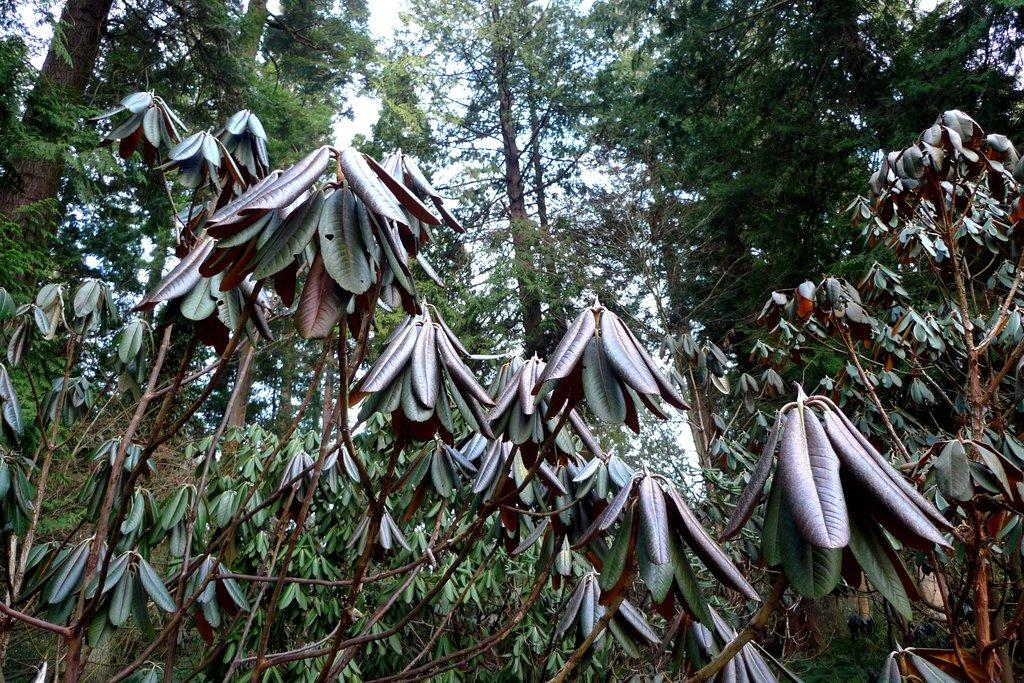What is located in the center of the image? There are trees in the center of the image. What can be seen in the background of the image? There is sky visible in the background of the image. What type of friction can be observed between the trees and the sky in the image? There is no friction between the trees and the sky in the image, as they are not in contact with each other. 